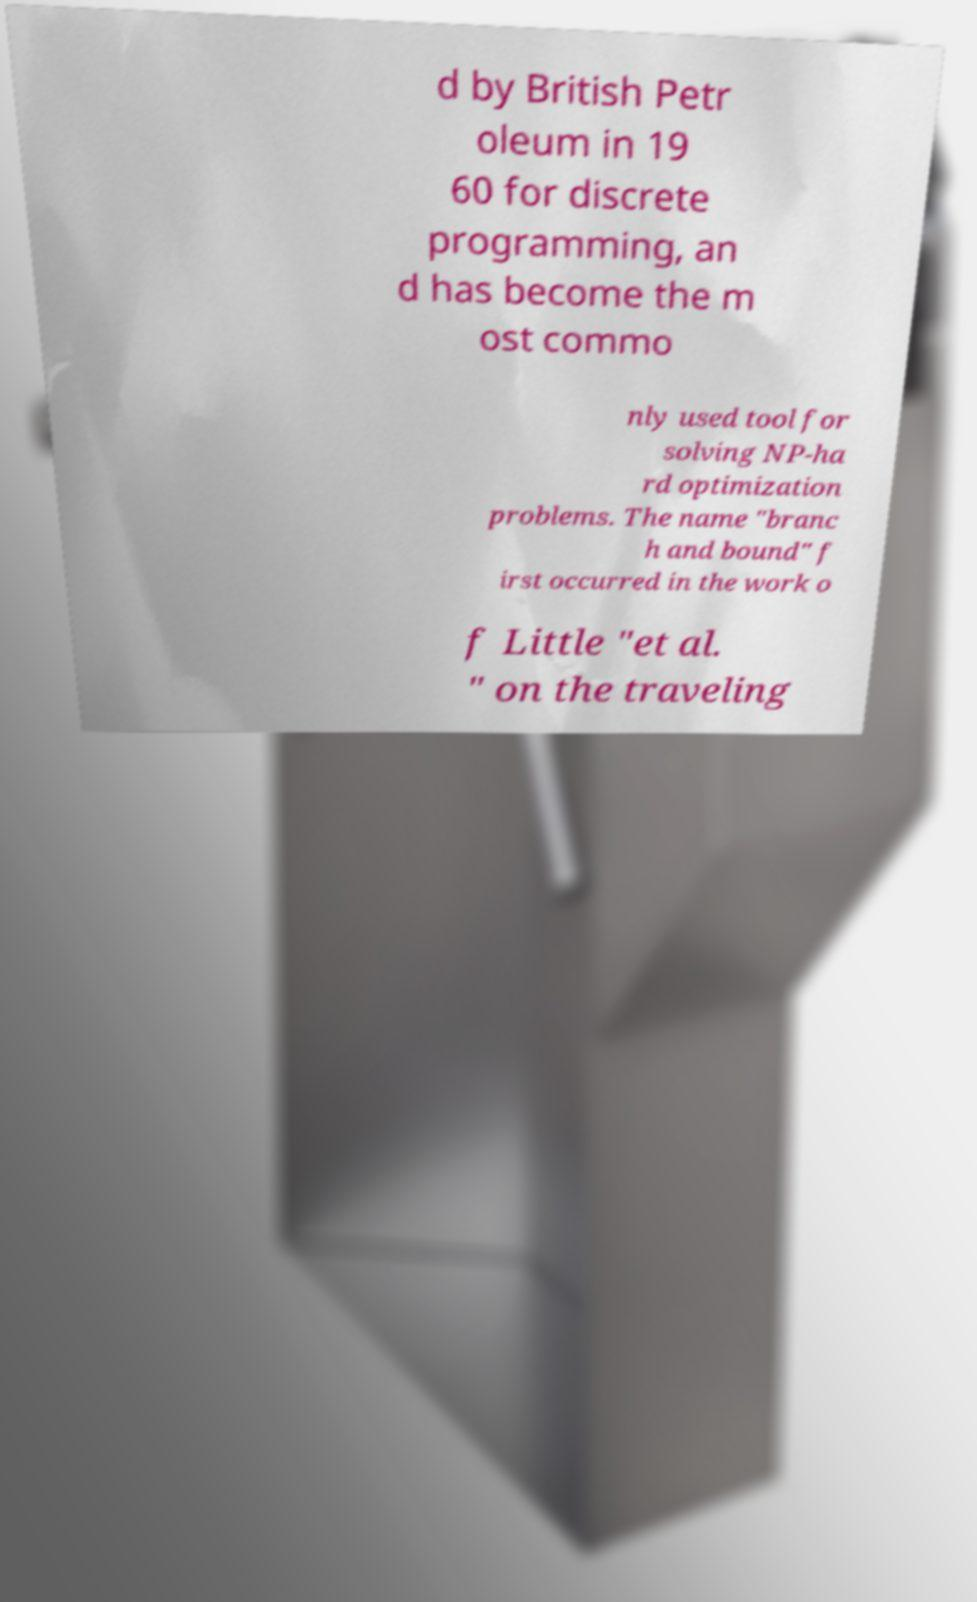Could you assist in decoding the text presented in this image and type it out clearly? d by British Petr oleum in 19 60 for discrete programming, an d has become the m ost commo nly used tool for solving NP-ha rd optimization problems. The name "branc h and bound" f irst occurred in the work o f Little "et al. " on the traveling 